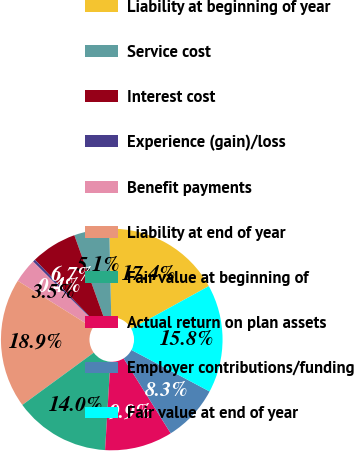Convert chart. <chart><loc_0><loc_0><loc_500><loc_500><pie_chart><fcel>Liability at beginning of year<fcel>Service cost<fcel>Interest cost<fcel>Experience (gain)/loss<fcel>Benefit payments<fcel>Liability at end of year<fcel>Fair value at beginning of<fcel>Actual return on plan assets<fcel>Employer contributions/funding<fcel>Fair value at end of year<nl><fcel>17.36%<fcel>5.13%<fcel>6.72%<fcel>0.37%<fcel>3.54%<fcel>18.94%<fcel>13.99%<fcel>9.89%<fcel>8.3%<fcel>15.77%<nl></chart> 